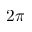<formula> <loc_0><loc_0><loc_500><loc_500>2 \pi</formula> 